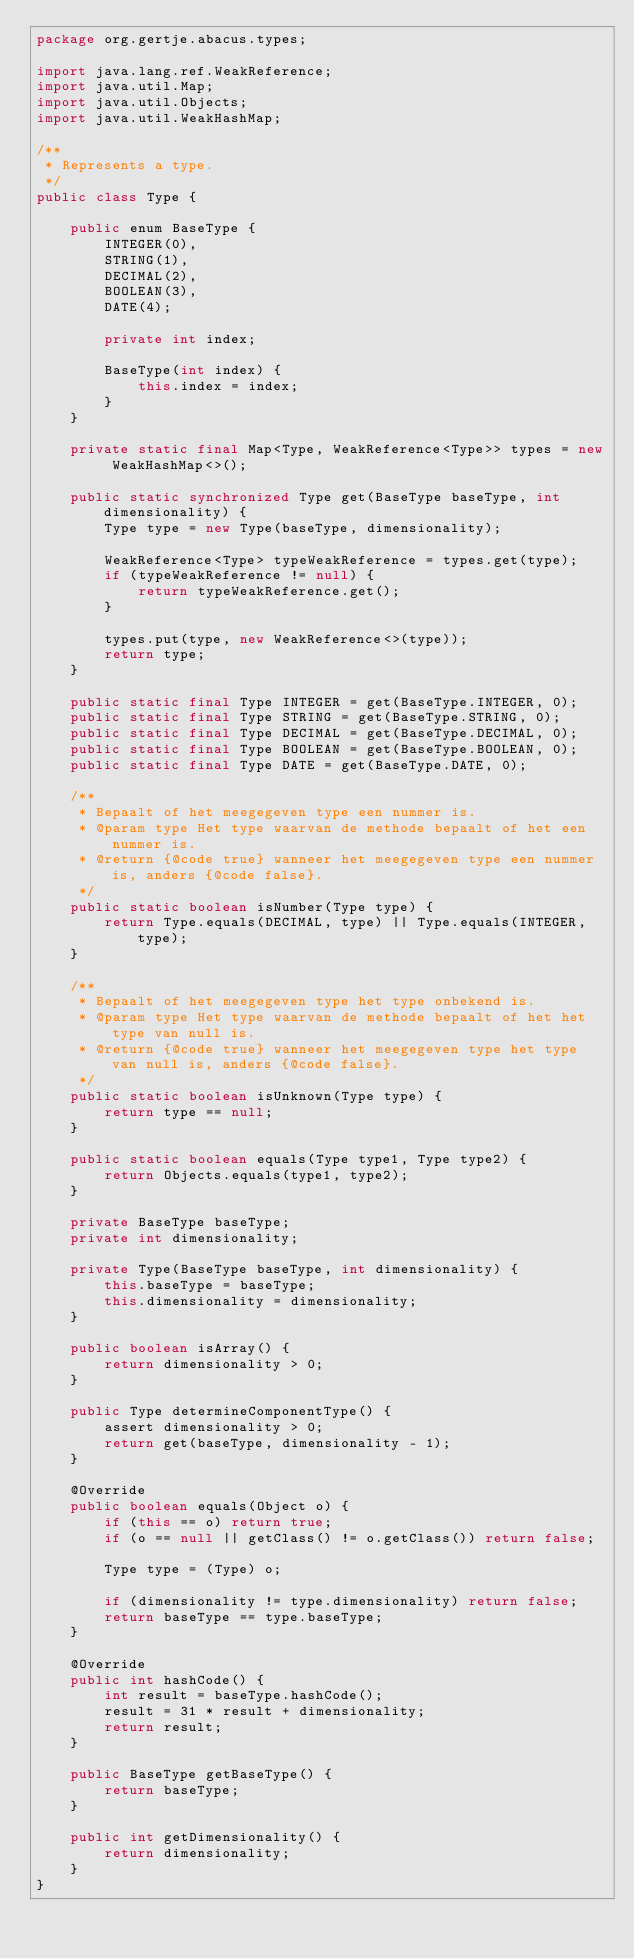<code> <loc_0><loc_0><loc_500><loc_500><_Java_>package org.gertje.abacus.types;

import java.lang.ref.WeakReference;
import java.util.Map;
import java.util.Objects;
import java.util.WeakHashMap;

/**
 * Represents a type.
 */
public class Type {

	public enum BaseType {
		INTEGER(0),
		STRING(1),
		DECIMAL(2),
		BOOLEAN(3),
		DATE(4);

		private int index;

		BaseType(int index) {
			this.index = index;
		}
	}

	private static final Map<Type, WeakReference<Type>> types = new WeakHashMap<>();

	public static synchronized Type get(BaseType baseType, int dimensionality) {
		Type type = new Type(baseType, dimensionality);

		WeakReference<Type> typeWeakReference = types.get(type);
		if (typeWeakReference != null) {
			return typeWeakReference.get();
		}

		types.put(type, new WeakReference<>(type));
		return type;
	}

	public static final Type INTEGER = get(BaseType.INTEGER, 0);
	public static final Type STRING = get(BaseType.STRING, 0);
	public static final Type DECIMAL = get(BaseType.DECIMAL, 0);
	public static final Type BOOLEAN = get(BaseType.BOOLEAN, 0);
	public static final Type DATE = get(BaseType.DATE, 0);

	/**
	 * Bepaalt of het meegegeven type een nummer is.
	 * @param type Het type waarvan de methode bepaalt of het een nummer is.
	 * @return {@code true} wanneer het meegegeven type een nummer is, anders {@code false}.
	 */
	public static boolean isNumber(Type type) {
		return Type.equals(DECIMAL, type) || Type.equals(INTEGER, type);
	}

	/**
	 * Bepaalt of het meegegeven type het type onbekend is.
	 * @param type Het type waarvan de methode bepaalt of het het type van null is.
	 * @return {@code true} wanneer het meegegeven type het type van null is, anders {@code false}.
	 */
	public static boolean isUnknown(Type type) {
		return type == null;
	}

	public static boolean equals(Type type1, Type type2) {
		return Objects.equals(type1, type2);
	}

	private BaseType baseType;
	private int dimensionality;

	private Type(BaseType baseType, int dimensionality) {
		this.baseType = baseType;
		this.dimensionality = dimensionality;
	}

	public boolean isArray() {
		return dimensionality > 0;
	}

	public Type determineComponentType() {
		assert dimensionality > 0;
		return get(baseType, dimensionality - 1);
	}

	@Override
	public boolean equals(Object o) {
		if (this == o) return true;
		if (o == null || getClass() != o.getClass()) return false;

		Type type = (Type) o;

		if (dimensionality != type.dimensionality) return false;
		return baseType == type.baseType;
	}

	@Override
	public int hashCode() {
		int result = baseType.hashCode();
		result = 31 * result + dimensionality;
		return result;
	}

	public BaseType getBaseType() {
		return baseType;
	}

	public int getDimensionality() {
		return dimensionality;
	}
}</code> 